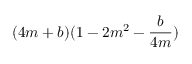<formula> <loc_0><loc_0><loc_500><loc_500>( 4 m + b ) ( 1 - 2 m ^ { 2 } - \frac { b } { 4 m } )</formula> 